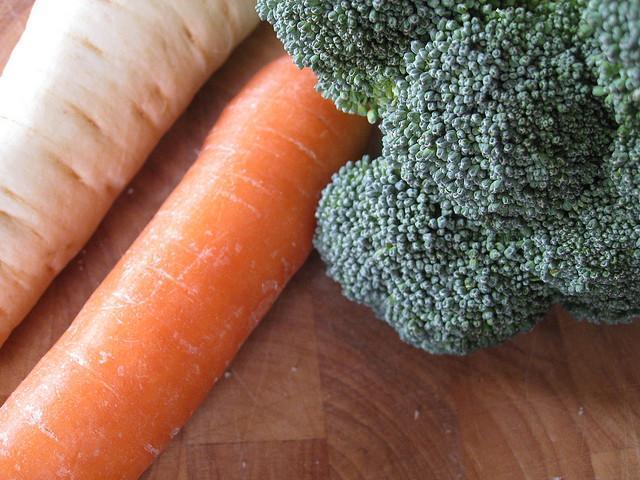How many carrots are there?
Give a very brief answer. 2. 